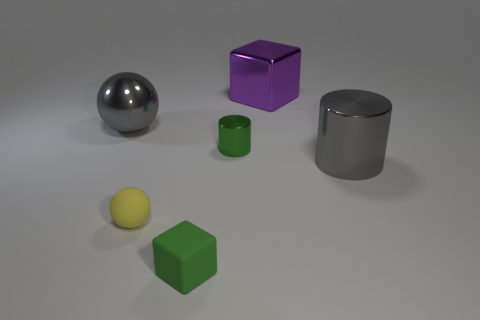Add 2 rubber spheres. How many objects exist? 8 Subtract all balls. How many objects are left? 4 Add 2 gray shiny things. How many gray shiny things are left? 4 Add 3 tiny green blocks. How many tiny green blocks exist? 4 Subtract 0 cyan blocks. How many objects are left? 6 Subtract all large shiny spheres. Subtract all small green cubes. How many objects are left? 4 